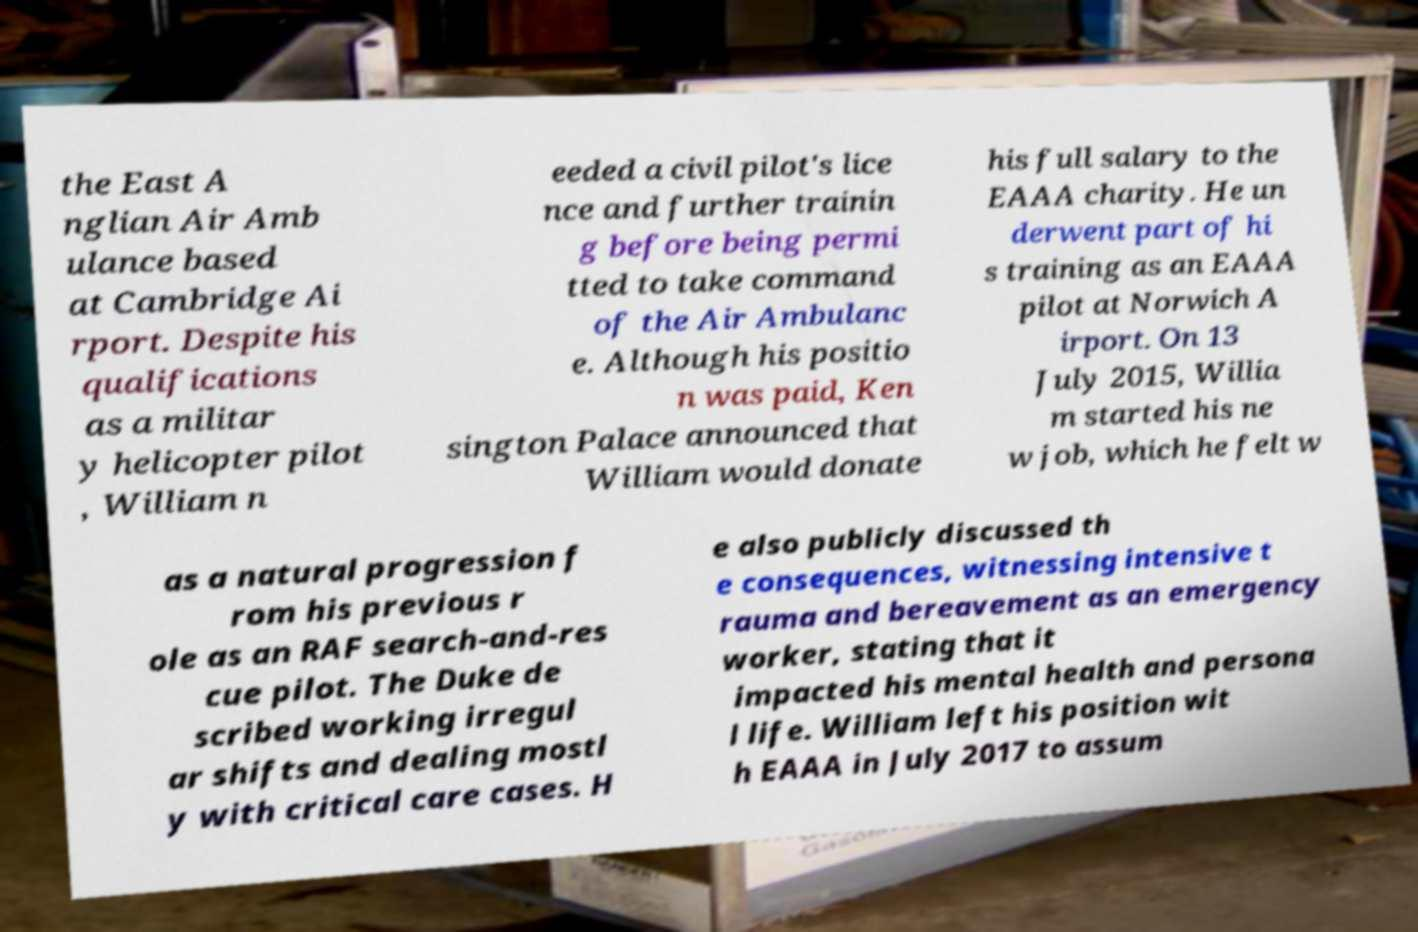I need the written content from this picture converted into text. Can you do that? the East A nglian Air Amb ulance based at Cambridge Ai rport. Despite his qualifications as a militar y helicopter pilot , William n eeded a civil pilot's lice nce and further trainin g before being permi tted to take command of the Air Ambulanc e. Although his positio n was paid, Ken sington Palace announced that William would donate his full salary to the EAAA charity. He un derwent part of hi s training as an EAAA pilot at Norwich A irport. On 13 July 2015, Willia m started his ne w job, which he felt w as a natural progression f rom his previous r ole as an RAF search-and-res cue pilot. The Duke de scribed working irregul ar shifts and dealing mostl y with critical care cases. H e also publicly discussed th e consequences, witnessing intensive t rauma and bereavement as an emergency worker, stating that it impacted his mental health and persona l life. William left his position wit h EAAA in July 2017 to assum 